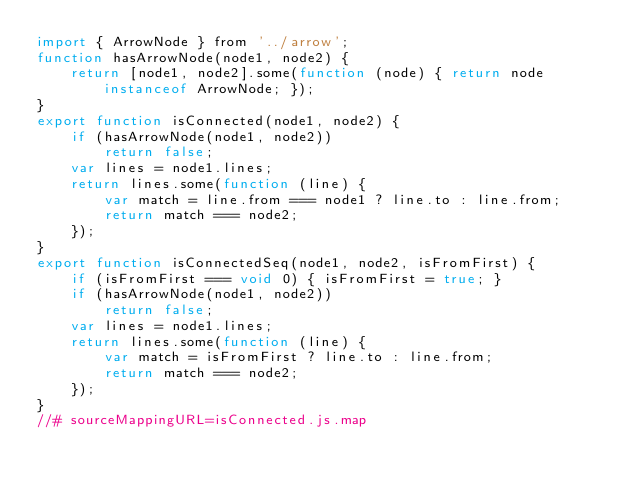<code> <loc_0><loc_0><loc_500><loc_500><_JavaScript_>import { ArrowNode } from '../arrow';
function hasArrowNode(node1, node2) {
    return [node1, node2].some(function (node) { return node instanceof ArrowNode; });
}
export function isConnected(node1, node2) {
    if (hasArrowNode(node1, node2))
        return false;
    var lines = node1.lines;
    return lines.some(function (line) {
        var match = line.from === node1 ? line.to : line.from;
        return match === node2;
    });
}
export function isConnectedSeq(node1, node2, isFromFirst) {
    if (isFromFirst === void 0) { isFromFirst = true; }
    if (hasArrowNode(node1, node2))
        return false;
    var lines = node1.lines;
    return lines.some(function (line) {
        var match = isFromFirst ? line.to : line.from;
        return match === node2;
    });
}
//# sourceMappingURL=isConnected.js.map</code> 